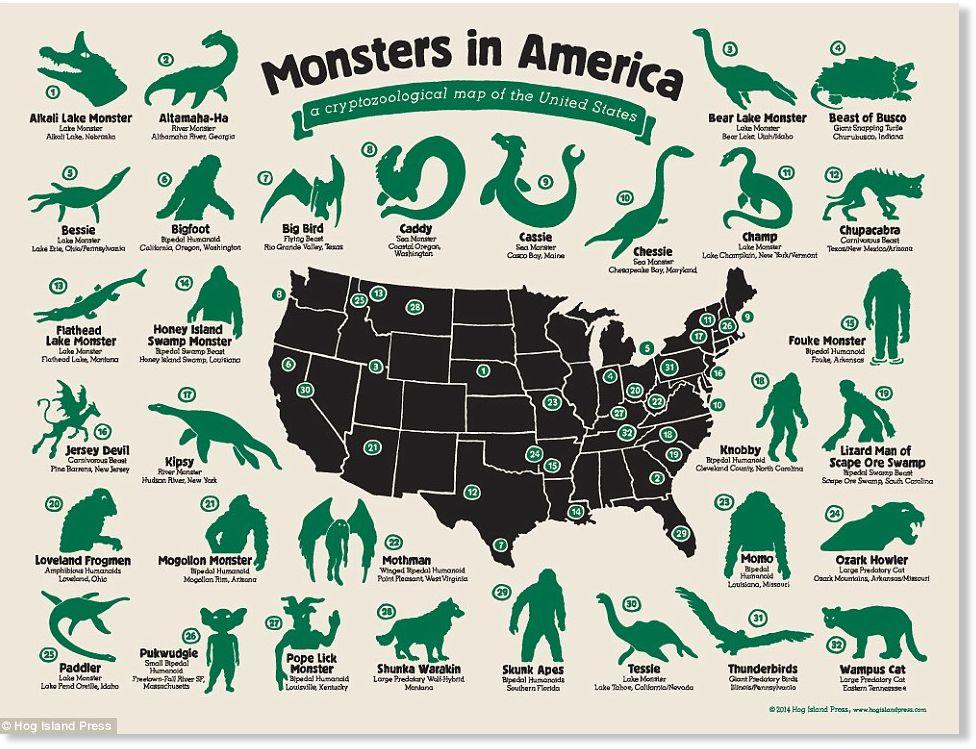Mention a couple of crucial points in this snapshot. There are 32 monsters listed in the infographic. The monster Skunk Apes are found predominantly in Southern Florida. It has been reported that a monster residing in the southernmost part of America is actually Big Bird. A sea monster has been found in Casco Bay, Maine. The name of the sea monster is Cassie. The 32nd monster is known as the Wampus Cat. 